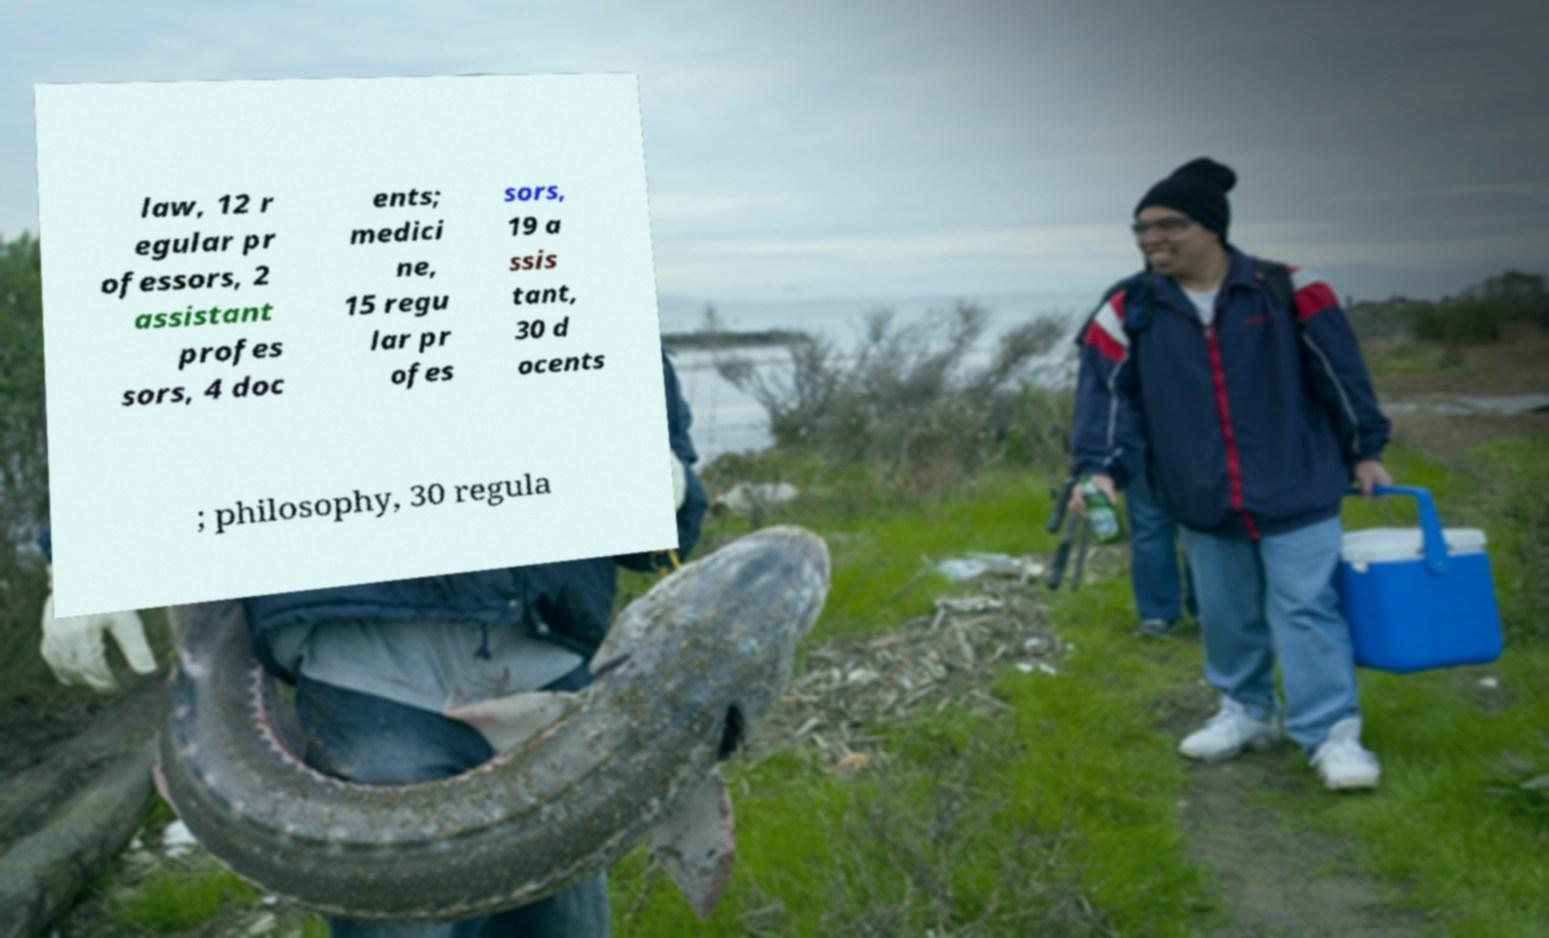Please read and relay the text visible in this image. What does it say? law, 12 r egular pr ofessors, 2 assistant profes sors, 4 doc ents; medici ne, 15 regu lar pr ofes sors, 19 a ssis tant, 30 d ocents ; philosophy, 30 regula 